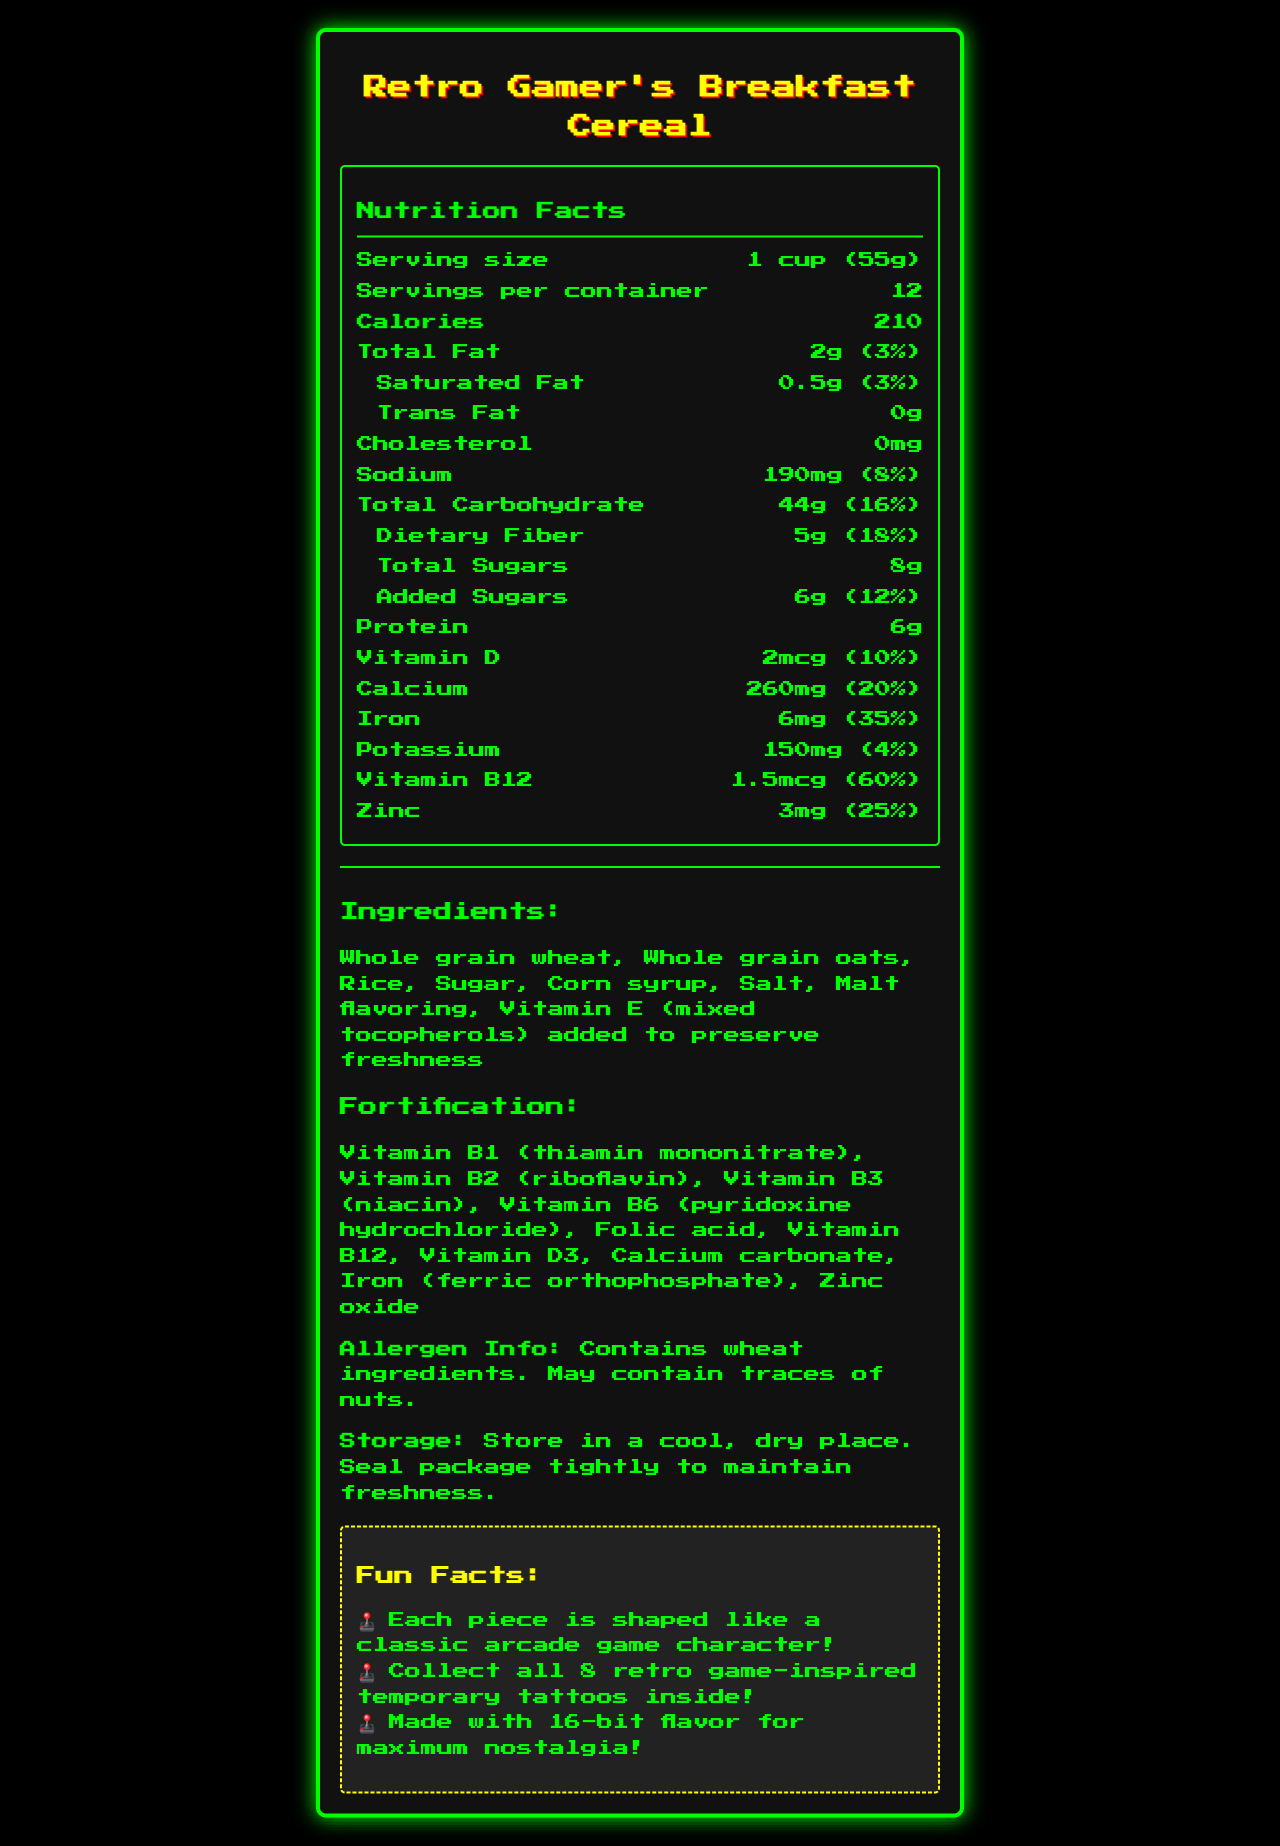how many calories are in one serving? The document states that there are 210 calories per serving.
Answer: 210 calories what is the serving size? The serving size specified in the document is 1 cup, which weighs 55 grams.
Answer: 1 cup (55g) how many grams of total sugars does one serving contain? The document states that one serving contains 8 grams of total sugars.
Answer: 8g which vitamin has the highest daily value percentage? A. Vitamin D B. Calcium C. Iron D. Vitamin B12 Vitamin B12 has a daily value percentage of 60%, which is the highest among the listed vitamins and minerals.
Answer: D. Vitamin B12 what is the total carbohydrate content per serving? The document specifies that the total carbohydrate content per serving is 44 grams.
Answer: 44g does the cereal contain trans fat? The document indicates that the cereal contains 0 grams of trans fat.
Answer: No how many grams of protein are in one serving of the cereal? The document indicates that each serving contains 6 grams of protein.
Answer: 6g which ingredient is not part of the cereal? I. Whole grain wheat II. Rice III. Sugar IV. Cocoa The ingredients listed include whole grain wheat, rice, sugar, but not cocoa.
Answer: IV. Cocoa what should be done to maintain the freshness of the cereal? The storage instructions in the document advise to seal the package tightly and store it in a cool, dry place to maintain freshness.
Answer: Seal package tightly and store in a cool, dry place how many servings are there per container? The document states that there are 12 servings per container.
Answer: 12 what are two fun features about the cereal for kids? The document mentions these two fun features about the cereal.
Answer: Shaped like classic arcade game characters and includes retro game-inspired temporary tattoos how much iron does one serving provide? The document specifies that one serving provides 6 milligrams of iron.
Answer: 6mg how much zinc is in one serving? According to the document The document states that one serving provides 3 milligrams of zinc.
Answer: 3mg is the cereal fortified with Vitamin D? The document lists Vitamin D3 in the fortification section, confirming the cereal is fortified with Vitamin D.
Answer: Yes what is the daily value percentage of calcium in one serving? The document specifies that one serving provides 20% of the daily value for calcium.
Answer: 20% summarize the main features of the Retro Gamer's Breakfast Cereal. This summary captures the key nutritional information, ingredient highlights, fun facts, and storage instructions of the cereal as stated in the document.
Answer: The Retro Gamer's Breakfast Cereal is a whole grain cereal containing essential nutrients like vitamins and minerals. Each serving is 1 cup (55g) with 210 calories. It contains 2g of total fat, 44g of carbohydrates, 8g of total sugars, and 6g of protein. The cereal is fortified with several vitamins and minerals and includes fun features like shapes of classic arcade game characters and retro game-inspired temporary tattoos. It should be stored in a cool, dry place. where is the cereal manufactured? The document does not provide any information about where the cereal is manufactured.
Answer: Cannot be determined 